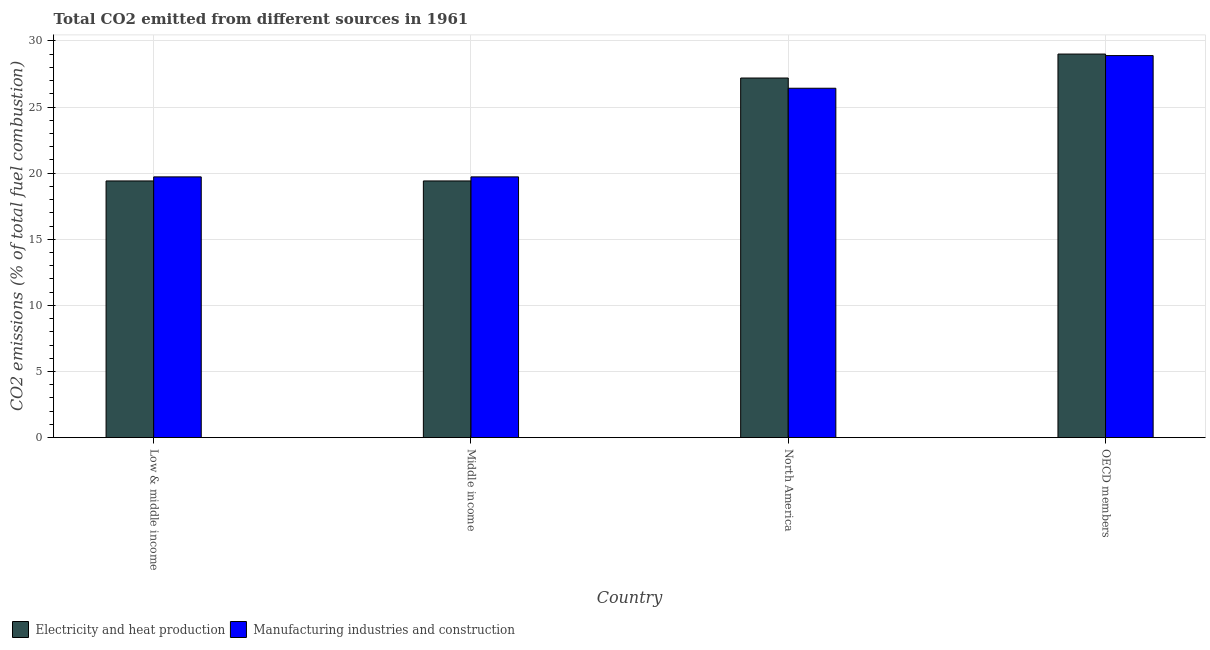How many groups of bars are there?
Make the answer very short. 4. Are the number of bars per tick equal to the number of legend labels?
Keep it short and to the point. Yes. Are the number of bars on each tick of the X-axis equal?
Your answer should be compact. Yes. How many bars are there on the 2nd tick from the left?
Offer a terse response. 2. What is the co2 emissions due to electricity and heat production in OECD members?
Provide a short and direct response. 29. Across all countries, what is the maximum co2 emissions due to manufacturing industries?
Make the answer very short. 28.89. Across all countries, what is the minimum co2 emissions due to manufacturing industries?
Your response must be concise. 19.72. What is the total co2 emissions due to manufacturing industries in the graph?
Your answer should be very brief. 94.74. What is the difference between the co2 emissions due to manufacturing industries in North America and that in OECD members?
Your response must be concise. -2.47. What is the difference between the co2 emissions due to electricity and heat production in Middle income and the co2 emissions due to manufacturing industries in Low & middle income?
Offer a very short reply. -0.31. What is the average co2 emissions due to electricity and heat production per country?
Give a very brief answer. 23.75. What is the difference between the co2 emissions due to manufacturing industries and co2 emissions due to electricity and heat production in North America?
Ensure brevity in your answer.  -0.77. In how many countries, is the co2 emissions due to electricity and heat production greater than 14 %?
Ensure brevity in your answer.  4. What is the ratio of the co2 emissions due to manufacturing industries in Low & middle income to that in North America?
Offer a terse response. 0.75. Is the co2 emissions due to electricity and heat production in North America less than that in OECD members?
Your answer should be compact. Yes. What is the difference between the highest and the second highest co2 emissions due to electricity and heat production?
Your answer should be compact. 1.81. What is the difference between the highest and the lowest co2 emissions due to manufacturing industries?
Your answer should be compact. 9.17. Is the sum of the co2 emissions due to electricity and heat production in Low & middle income and North America greater than the maximum co2 emissions due to manufacturing industries across all countries?
Provide a succinct answer. Yes. What does the 2nd bar from the left in OECD members represents?
Keep it short and to the point. Manufacturing industries and construction. What does the 1st bar from the right in Middle income represents?
Provide a succinct answer. Manufacturing industries and construction. How many bars are there?
Your response must be concise. 8. Are all the bars in the graph horizontal?
Provide a short and direct response. No. What is the difference between two consecutive major ticks on the Y-axis?
Provide a succinct answer. 5. Are the values on the major ticks of Y-axis written in scientific E-notation?
Ensure brevity in your answer.  No. Does the graph contain any zero values?
Keep it short and to the point. No. How many legend labels are there?
Give a very brief answer. 2. What is the title of the graph?
Offer a very short reply. Total CO2 emitted from different sources in 1961. Does "Revenue" appear as one of the legend labels in the graph?
Keep it short and to the point. No. What is the label or title of the Y-axis?
Your answer should be compact. CO2 emissions (% of total fuel combustion). What is the CO2 emissions (% of total fuel combustion) in Electricity and heat production in Low & middle income?
Provide a succinct answer. 19.41. What is the CO2 emissions (% of total fuel combustion) of Manufacturing industries and construction in Low & middle income?
Give a very brief answer. 19.72. What is the CO2 emissions (% of total fuel combustion) of Electricity and heat production in Middle income?
Offer a very short reply. 19.41. What is the CO2 emissions (% of total fuel combustion) in Manufacturing industries and construction in Middle income?
Offer a terse response. 19.72. What is the CO2 emissions (% of total fuel combustion) of Electricity and heat production in North America?
Keep it short and to the point. 27.19. What is the CO2 emissions (% of total fuel combustion) of Manufacturing industries and construction in North America?
Your answer should be compact. 26.42. What is the CO2 emissions (% of total fuel combustion) of Electricity and heat production in OECD members?
Ensure brevity in your answer.  29. What is the CO2 emissions (% of total fuel combustion) of Manufacturing industries and construction in OECD members?
Ensure brevity in your answer.  28.89. Across all countries, what is the maximum CO2 emissions (% of total fuel combustion) of Electricity and heat production?
Make the answer very short. 29. Across all countries, what is the maximum CO2 emissions (% of total fuel combustion) of Manufacturing industries and construction?
Make the answer very short. 28.89. Across all countries, what is the minimum CO2 emissions (% of total fuel combustion) of Electricity and heat production?
Provide a short and direct response. 19.41. Across all countries, what is the minimum CO2 emissions (% of total fuel combustion) in Manufacturing industries and construction?
Your response must be concise. 19.72. What is the total CO2 emissions (% of total fuel combustion) in Electricity and heat production in the graph?
Keep it short and to the point. 95.01. What is the total CO2 emissions (% of total fuel combustion) in Manufacturing industries and construction in the graph?
Your response must be concise. 94.74. What is the difference between the CO2 emissions (% of total fuel combustion) of Electricity and heat production in Low & middle income and that in Middle income?
Give a very brief answer. 0. What is the difference between the CO2 emissions (% of total fuel combustion) of Manufacturing industries and construction in Low & middle income and that in Middle income?
Provide a short and direct response. 0. What is the difference between the CO2 emissions (% of total fuel combustion) of Electricity and heat production in Low & middle income and that in North America?
Your answer should be very brief. -7.78. What is the difference between the CO2 emissions (% of total fuel combustion) of Manufacturing industries and construction in Low & middle income and that in North America?
Keep it short and to the point. -6.7. What is the difference between the CO2 emissions (% of total fuel combustion) in Electricity and heat production in Low & middle income and that in OECD members?
Provide a succinct answer. -9.6. What is the difference between the CO2 emissions (% of total fuel combustion) of Manufacturing industries and construction in Low & middle income and that in OECD members?
Your answer should be very brief. -9.17. What is the difference between the CO2 emissions (% of total fuel combustion) in Electricity and heat production in Middle income and that in North America?
Offer a terse response. -7.78. What is the difference between the CO2 emissions (% of total fuel combustion) in Manufacturing industries and construction in Middle income and that in North America?
Provide a succinct answer. -6.7. What is the difference between the CO2 emissions (% of total fuel combustion) of Electricity and heat production in Middle income and that in OECD members?
Make the answer very short. -9.6. What is the difference between the CO2 emissions (% of total fuel combustion) in Manufacturing industries and construction in Middle income and that in OECD members?
Provide a succinct answer. -9.17. What is the difference between the CO2 emissions (% of total fuel combustion) in Electricity and heat production in North America and that in OECD members?
Give a very brief answer. -1.81. What is the difference between the CO2 emissions (% of total fuel combustion) of Manufacturing industries and construction in North America and that in OECD members?
Offer a terse response. -2.47. What is the difference between the CO2 emissions (% of total fuel combustion) in Electricity and heat production in Low & middle income and the CO2 emissions (% of total fuel combustion) in Manufacturing industries and construction in Middle income?
Give a very brief answer. -0.31. What is the difference between the CO2 emissions (% of total fuel combustion) of Electricity and heat production in Low & middle income and the CO2 emissions (% of total fuel combustion) of Manufacturing industries and construction in North America?
Your response must be concise. -7.01. What is the difference between the CO2 emissions (% of total fuel combustion) in Electricity and heat production in Low & middle income and the CO2 emissions (% of total fuel combustion) in Manufacturing industries and construction in OECD members?
Provide a succinct answer. -9.48. What is the difference between the CO2 emissions (% of total fuel combustion) in Electricity and heat production in Middle income and the CO2 emissions (% of total fuel combustion) in Manufacturing industries and construction in North America?
Make the answer very short. -7.01. What is the difference between the CO2 emissions (% of total fuel combustion) of Electricity and heat production in Middle income and the CO2 emissions (% of total fuel combustion) of Manufacturing industries and construction in OECD members?
Make the answer very short. -9.48. What is the difference between the CO2 emissions (% of total fuel combustion) in Electricity and heat production in North America and the CO2 emissions (% of total fuel combustion) in Manufacturing industries and construction in OECD members?
Provide a succinct answer. -1.7. What is the average CO2 emissions (% of total fuel combustion) of Electricity and heat production per country?
Ensure brevity in your answer.  23.75. What is the average CO2 emissions (% of total fuel combustion) in Manufacturing industries and construction per country?
Offer a terse response. 23.69. What is the difference between the CO2 emissions (% of total fuel combustion) in Electricity and heat production and CO2 emissions (% of total fuel combustion) in Manufacturing industries and construction in Low & middle income?
Your response must be concise. -0.31. What is the difference between the CO2 emissions (% of total fuel combustion) of Electricity and heat production and CO2 emissions (% of total fuel combustion) of Manufacturing industries and construction in Middle income?
Your response must be concise. -0.31. What is the difference between the CO2 emissions (% of total fuel combustion) of Electricity and heat production and CO2 emissions (% of total fuel combustion) of Manufacturing industries and construction in North America?
Make the answer very short. 0.77. What is the difference between the CO2 emissions (% of total fuel combustion) in Electricity and heat production and CO2 emissions (% of total fuel combustion) in Manufacturing industries and construction in OECD members?
Your response must be concise. 0.12. What is the ratio of the CO2 emissions (% of total fuel combustion) of Electricity and heat production in Low & middle income to that in North America?
Your answer should be compact. 0.71. What is the ratio of the CO2 emissions (% of total fuel combustion) of Manufacturing industries and construction in Low & middle income to that in North America?
Give a very brief answer. 0.75. What is the ratio of the CO2 emissions (% of total fuel combustion) of Electricity and heat production in Low & middle income to that in OECD members?
Your answer should be very brief. 0.67. What is the ratio of the CO2 emissions (% of total fuel combustion) of Manufacturing industries and construction in Low & middle income to that in OECD members?
Offer a very short reply. 0.68. What is the ratio of the CO2 emissions (% of total fuel combustion) in Electricity and heat production in Middle income to that in North America?
Your answer should be compact. 0.71. What is the ratio of the CO2 emissions (% of total fuel combustion) in Manufacturing industries and construction in Middle income to that in North America?
Make the answer very short. 0.75. What is the ratio of the CO2 emissions (% of total fuel combustion) of Electricity and heat production in Middle income to that in OECD members?
Your answer should be very brief. 0.67. What is the ratio of the CO2 emissions (% of total fuel combustion) in Manufacturing industries and construction in Middle income to that in OECD members?
Keep it short and to the point. 0.68. What is the ratio of the CO2 emissions (% of total fuel combustion) of Manufacturing industries and construction in North America to that in OECD members?
Give a very brief answer. 0.91. What is the difference between the highest and the second highest CO2 emissions (% of total fuel combustion) of Electricity and heat production?
Keep it short and to the point. 1.81. What is the difference between the highest and the second highest CO2 emissions (% of total fuel combustion) in Manufacturing industries and construction?
Your response must be concise. 2.47. What is the difference between the highest and the lowest CO2 emissions (% of total fuel combustion) in Electricity and heat production?
Provide a succinct answer. 9.6. What is the difference between the highest and the lowest CO2 emissions (% of total fuel combustion) in Manufacturing industries and construction?
Make the answer very short. 9.17. 